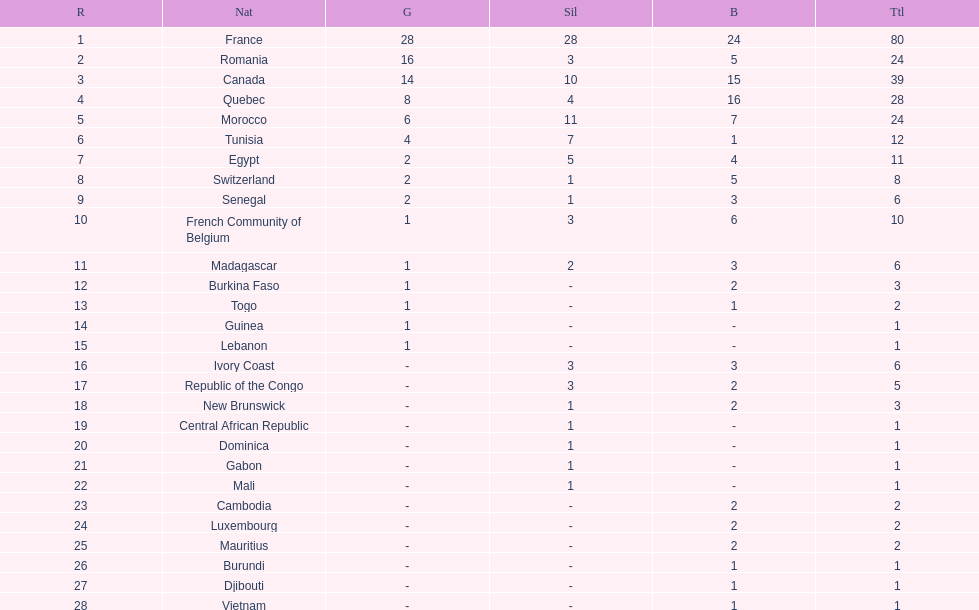How many bronze medals does togo have? 1. 